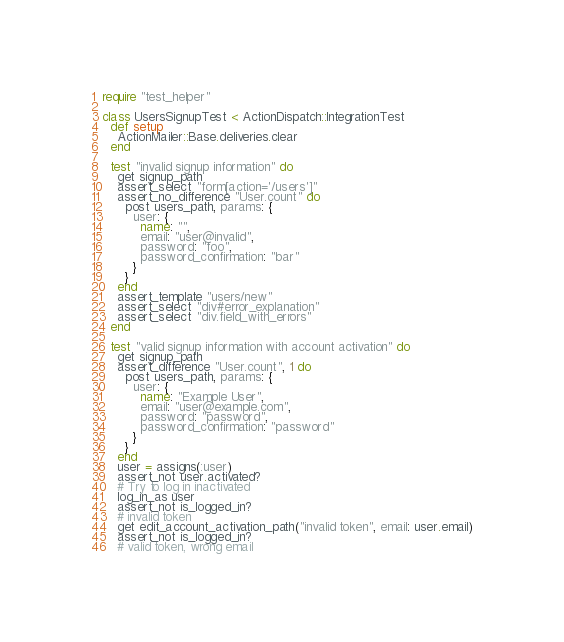Convert code to text. <code><loc_0><loc_0><loc_500><loc_500><_Ruby_>require "test_helper"

class UsersSignupTest < ActionDispatch::IntegrationTest
  def setup
    ActionMailer::Base.deliveries.clear
  end

  test "invalid signup information" do
    get signup_path
    assert_select "form[action='/users']"
    assert_no_difference "User.count" do
      post users_path, params: {
        user: {
          name: "",
          email: "user@invalid",
          password: "foo",
          password_confirmation: "bar"
        }
      }
    end
    assert_template "users/new"
    assert_select "div#error_explanation"
    assert_select "div.field_with_errors"
  end

  test "valid signup information with account activation" do
    get signup_path
    assert_difference "User.count", 1 do
      post users_path, params: {
        user: {
          name: "Example User",
          email: "user@example.com",
          password: "password",
          password_confirmation: "password"
        }
      }
    end
    user = assigns(:user)
    assert_not user.activated?
    # Try to log in inactivated
    log_in_as user
    assert_not is_logged_in?
    # invalid token
    get edit_account_activation_path("invalid token", email: user.email)
    assert_not is_logged_in?
    # valid token, wrong email</code> 